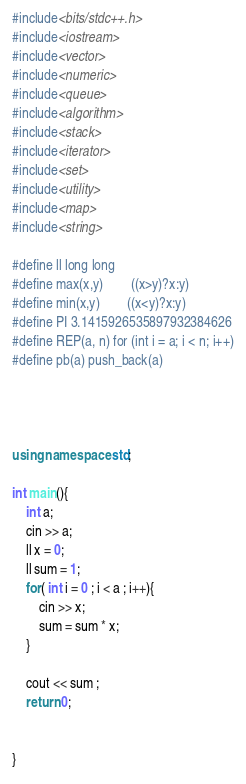<code> <loc_0><loc_0><loc_500><loc_500><_C++_>
#include<bits/stdc++.h>
#include<iostream>
#include<vector>
#include<numeric>
#include<queue>
#include<algorithm>
#include<stack>
#include<iterator>
#include<set>
#include<utility>
#include<map>
#include<string>

#define ll long long
#define max(x,y)        ((x>y)?x:y)
#define min(x,y)        ((x<y)?x:y)
#define PI 3.1415926535897932384626
#define REP(a, n) for (int i = a; i < n; i++)
#define pb(a) push_back(a)




using namespace std;

int main(){
	int a;
	cin >> a;
	ll x = 0;
	ll sum = 1;
	for( int i = 0 ; i < a ; i++){
		cin >> x;
		sum = sum * x;
	}
	
	cout << sum ;
	return 0;
		
	
}
</code> 